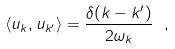Convert formula to latex. <formula><loc_0><loc_0><loc_500><loc_500>\langle u _ { k } , u _ { k ^ { \prime } } \rangle = \frac { \delta ( k - k ^ { \prime } ) } { 2 \omega _ { k } } \ ,</formula> 